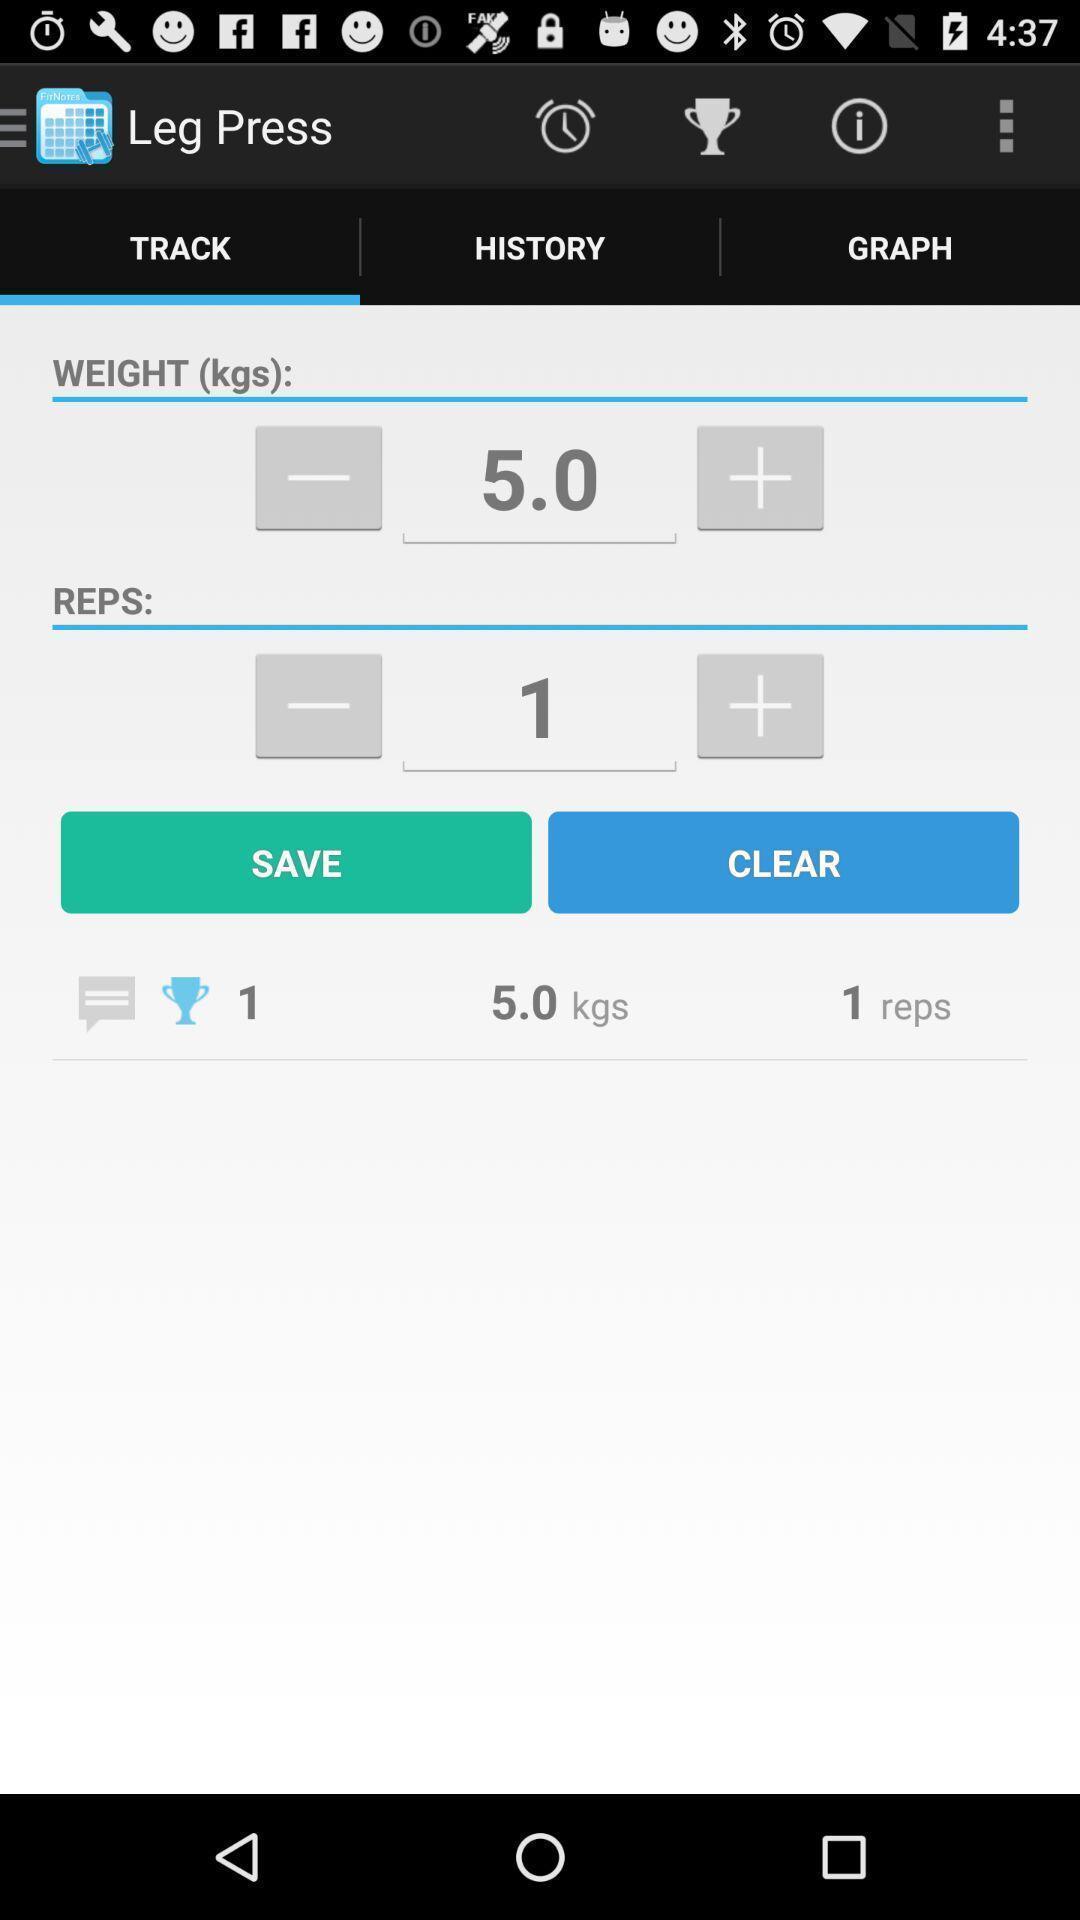Describe the content in this image. Page showing options in a workout tracking app. 